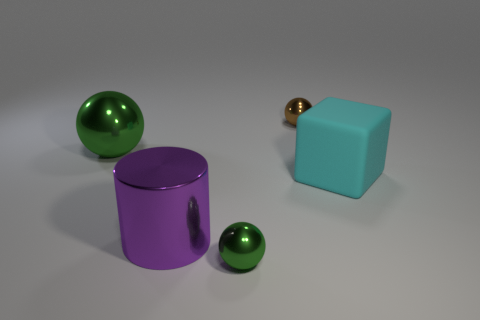Subtract all large green balls. How many balls are left? 2 Add 1 blocks. How many objects exist? 6 Subtract all brown spheres. How many spheres are left? 2 Subtract all balls. How many objects are left? 2 Subtract all red balls. How many yellow blocks are left? 0 Subtract all big green metallic blocks. Subtract all green balls. How many objects are left? 3 Add 1 big purple metal cylinders. How many big purple metal cylinders are left? 2 Add 1 purple shiny cylinders. How many purple shiny cylinders exist? 2 Subtract 0 gray cylinders. How many objects are left? 5 Subtract 1 balls. How many balls are left? 2 